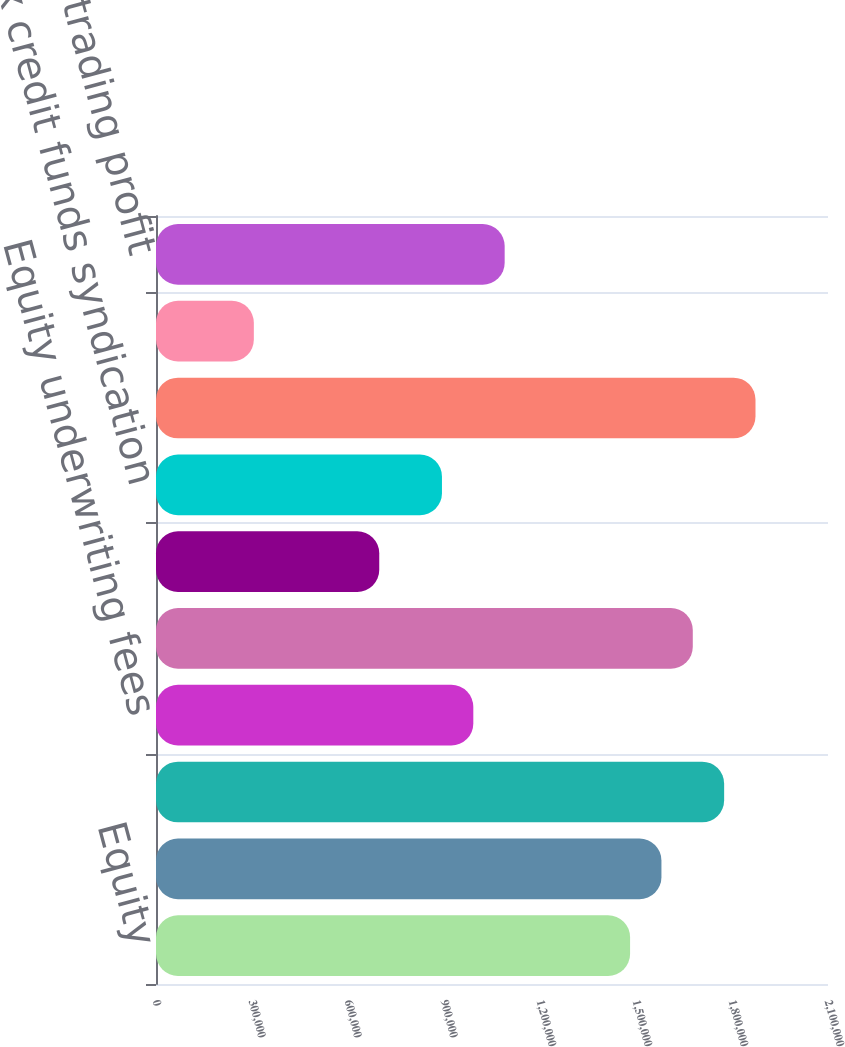Convert chart. <chart><loc_0><loc_0><loc_500><loc_500><bar_chart><fcel>Equity<fcel>Fixed income<fcel>Subtotal securities<fcel>Equity underwriting fees<fcel>Merger & acquisition and<fcel>Fixed income investment<fcel>Tax credit funds syndication<fcel>Subtotal investment banking<fcel>Investment advisory fees<fcel>Net trading profit<nl><fcel>1.4815e+06<fcel>1.57949e+06<fcel>1.77545e+06<fcel>991604<fcel>1.67747e+06<fcel>697663<fcel>893624<fcel>1.87343e+06<fcel>305743<fcel>1.08958e+06<nl></chart> 